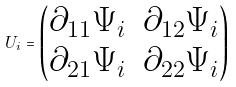Convert formula to latex. <formula><loc_0><loc_0><loc_500><loc_500>U _ { i } = \begin{pmatrix} \partial _ { 1 1 } \Psi _ { i } & \partial _ { 1 2 } \Psi _ { i } \\ \partial _ { 2 1 } \Psi _ { i } & \partial _ { 2 2 } \Psi _ { i } \end{pmatrix}</formula> 